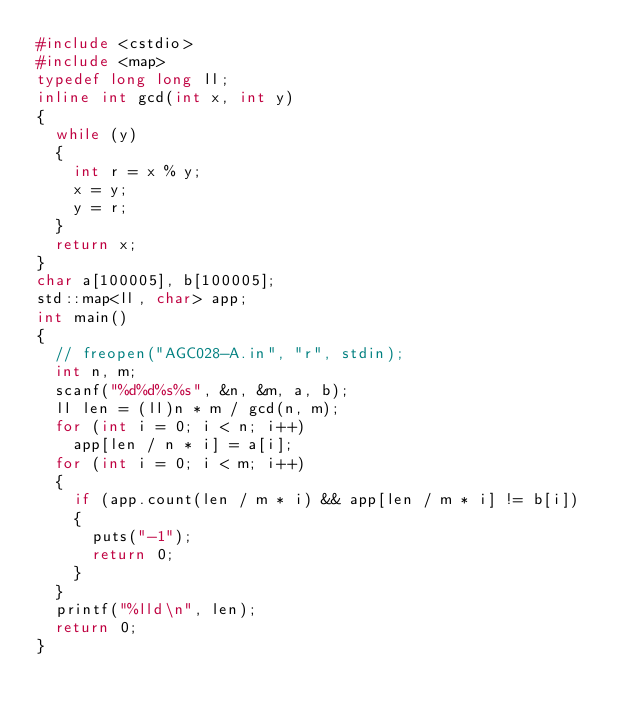Convert code to text. <code><loc_0><loc_0><loc_500><loc_500><_C++_>#include <cstdio>
#include <map>
typedef long long ll;
inline int gcd(int x, int y)
{
	while (y)
	{
		int r = x % y;
		x = y;
		y = r;
	}
	return x;
}
char a[100005], b[100005];
std::map<ll, char> app;
int main()
{
	// freopen("AGC028-A.in", "r", stdin);
	int n, m;
	scanf("%d%d%s%s", &n, &m, a, b);
	ll len = (ll)n * m / gcd(n, m);
	for (int i = 0; i < n; i++)
		app[len / n * i] = a[i];
	for (int i = 0; i < m; i++)
	{
		if (app.count(len / m * i) && app[len / m * i] != b[i])
		{
			puts("-1");
			return 0;
		}
	}
	printf("%lld\n", len);
	return 0;
}
</code> 